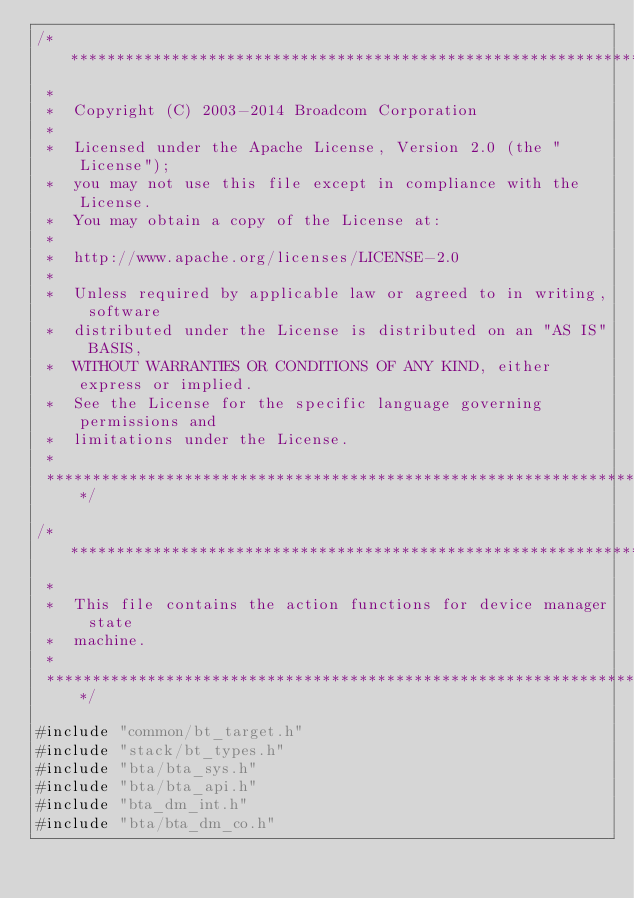<code> <loc_0><loc_0><loc_500><loc_500><_C_>/******************************************************************************
 *
 *  Copyright (C) 2003-2014 Broadcom Corporation
 *
 *  Licensed under the Apache License, Version 2.0 (the "License");
 *  you may not use this file except in compliance with the License.
 *  You may obtain a copy of the License at:
 *
 *  http://www.apache.org/licenses/LICENSE-2.0
 *
 *  Unless required by applicable law or agreed to in writing, software
 *  distributed under the License is distributed on an "AS IS" BASIS,
 *  WITHOUT WARRANTIES OR CONDITIONS OF ANY KIND, either express or implied.
 *  See the License for the specific language governing permissions and
 *  limitations under the License.
 *
 ******************************************************************************/

/******************************************************************************
 *
 *  This file contains the action functions for device manager state
 *  machine.
 *
 ******************************************************************************/

#include "common/bt_target.h"
#include "stack/bt_types.h"
#include "bta/bta_sys.h"
#include "bta/bta_api.h"
#include "bta_dm_int.h"
#include "bta/bta_dm_co.h"</code> 